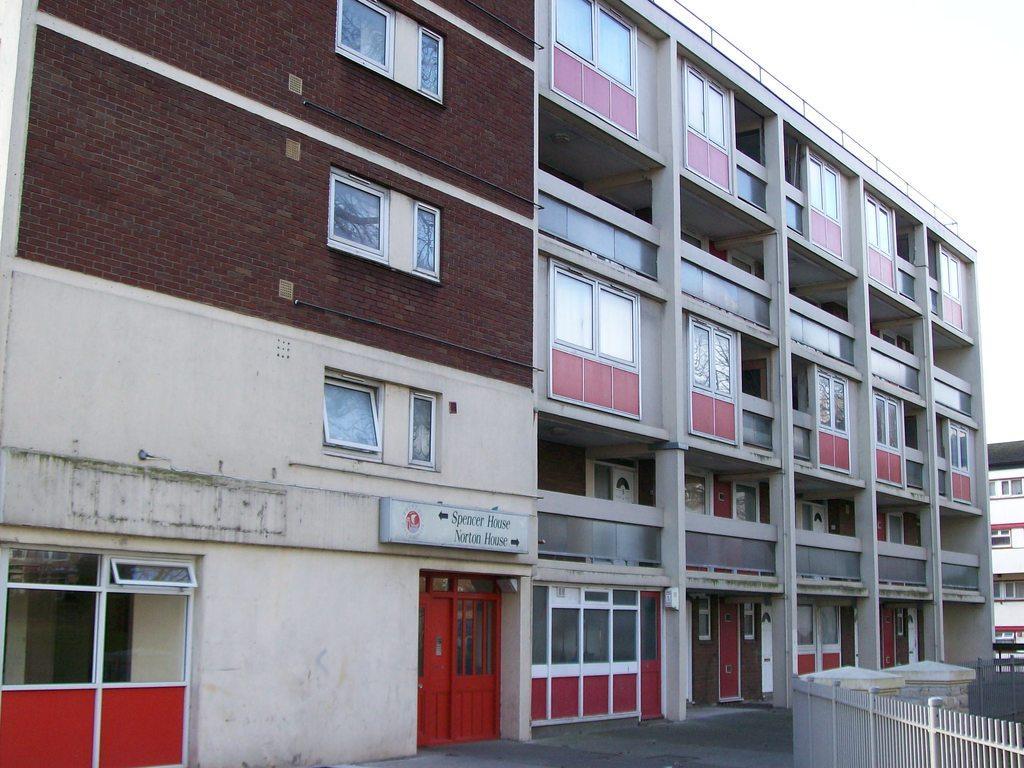Please provide a concise description of this image. In this image there is the sky truncated towards the top of the image, there is a building, there are windows, there is a board on the building, there is text on the board, there are doors, there is a fencing truncated towards the bottom of the image, there is a building truncated towards the right of the image, there is an object truncated towards the right of the image, at the bottom of the image there is the road truncated. 